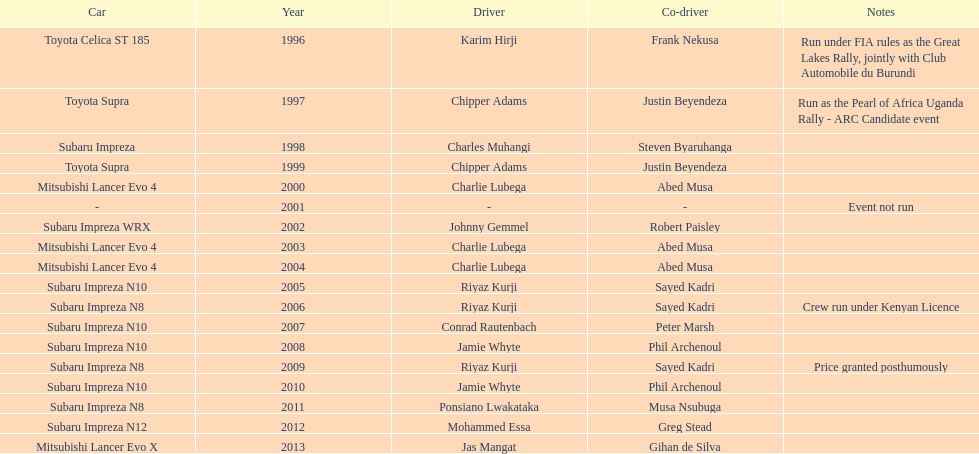Do chipper adams and justin beyendeza have more than 3 wins? No. 